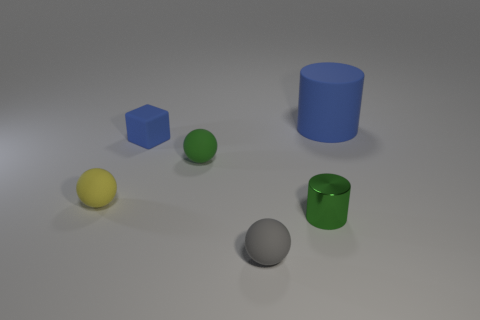Do the small rubber thing in front of the shiny cylinder and the small cylinder have the same color?
Provide a succinct answer. No. The blue rubber cylinder has what size?
Provide a short and direct response. Large. There is a blue cube that is the same size as the yellow matte ball; what is its material?
Your answer should be very brief. Rubber. There is a cylinder to the left of the blue rubber cylinder; what is its color?
Your answer should be very brief. Green. What number of shiny things are there?
Provide a short and direct response. 1. There is a matte ball that is left of the blue rubber object that is in front of the large cylinder; are there any yellow matte things behind it?
Provide a succinct answer. No. What is the shape of the shiny thing that is the same size as the blue rubber block?
Give a very brief answer. Cylinder. How many other objects are the same color as the matte cylinder?
Offer a very short reply. 1. What material is the yellow thing?
Your answer should be very brief. Rubber. How many other objects are there of the same material as the green ball?
Your response must be concise. 4. 